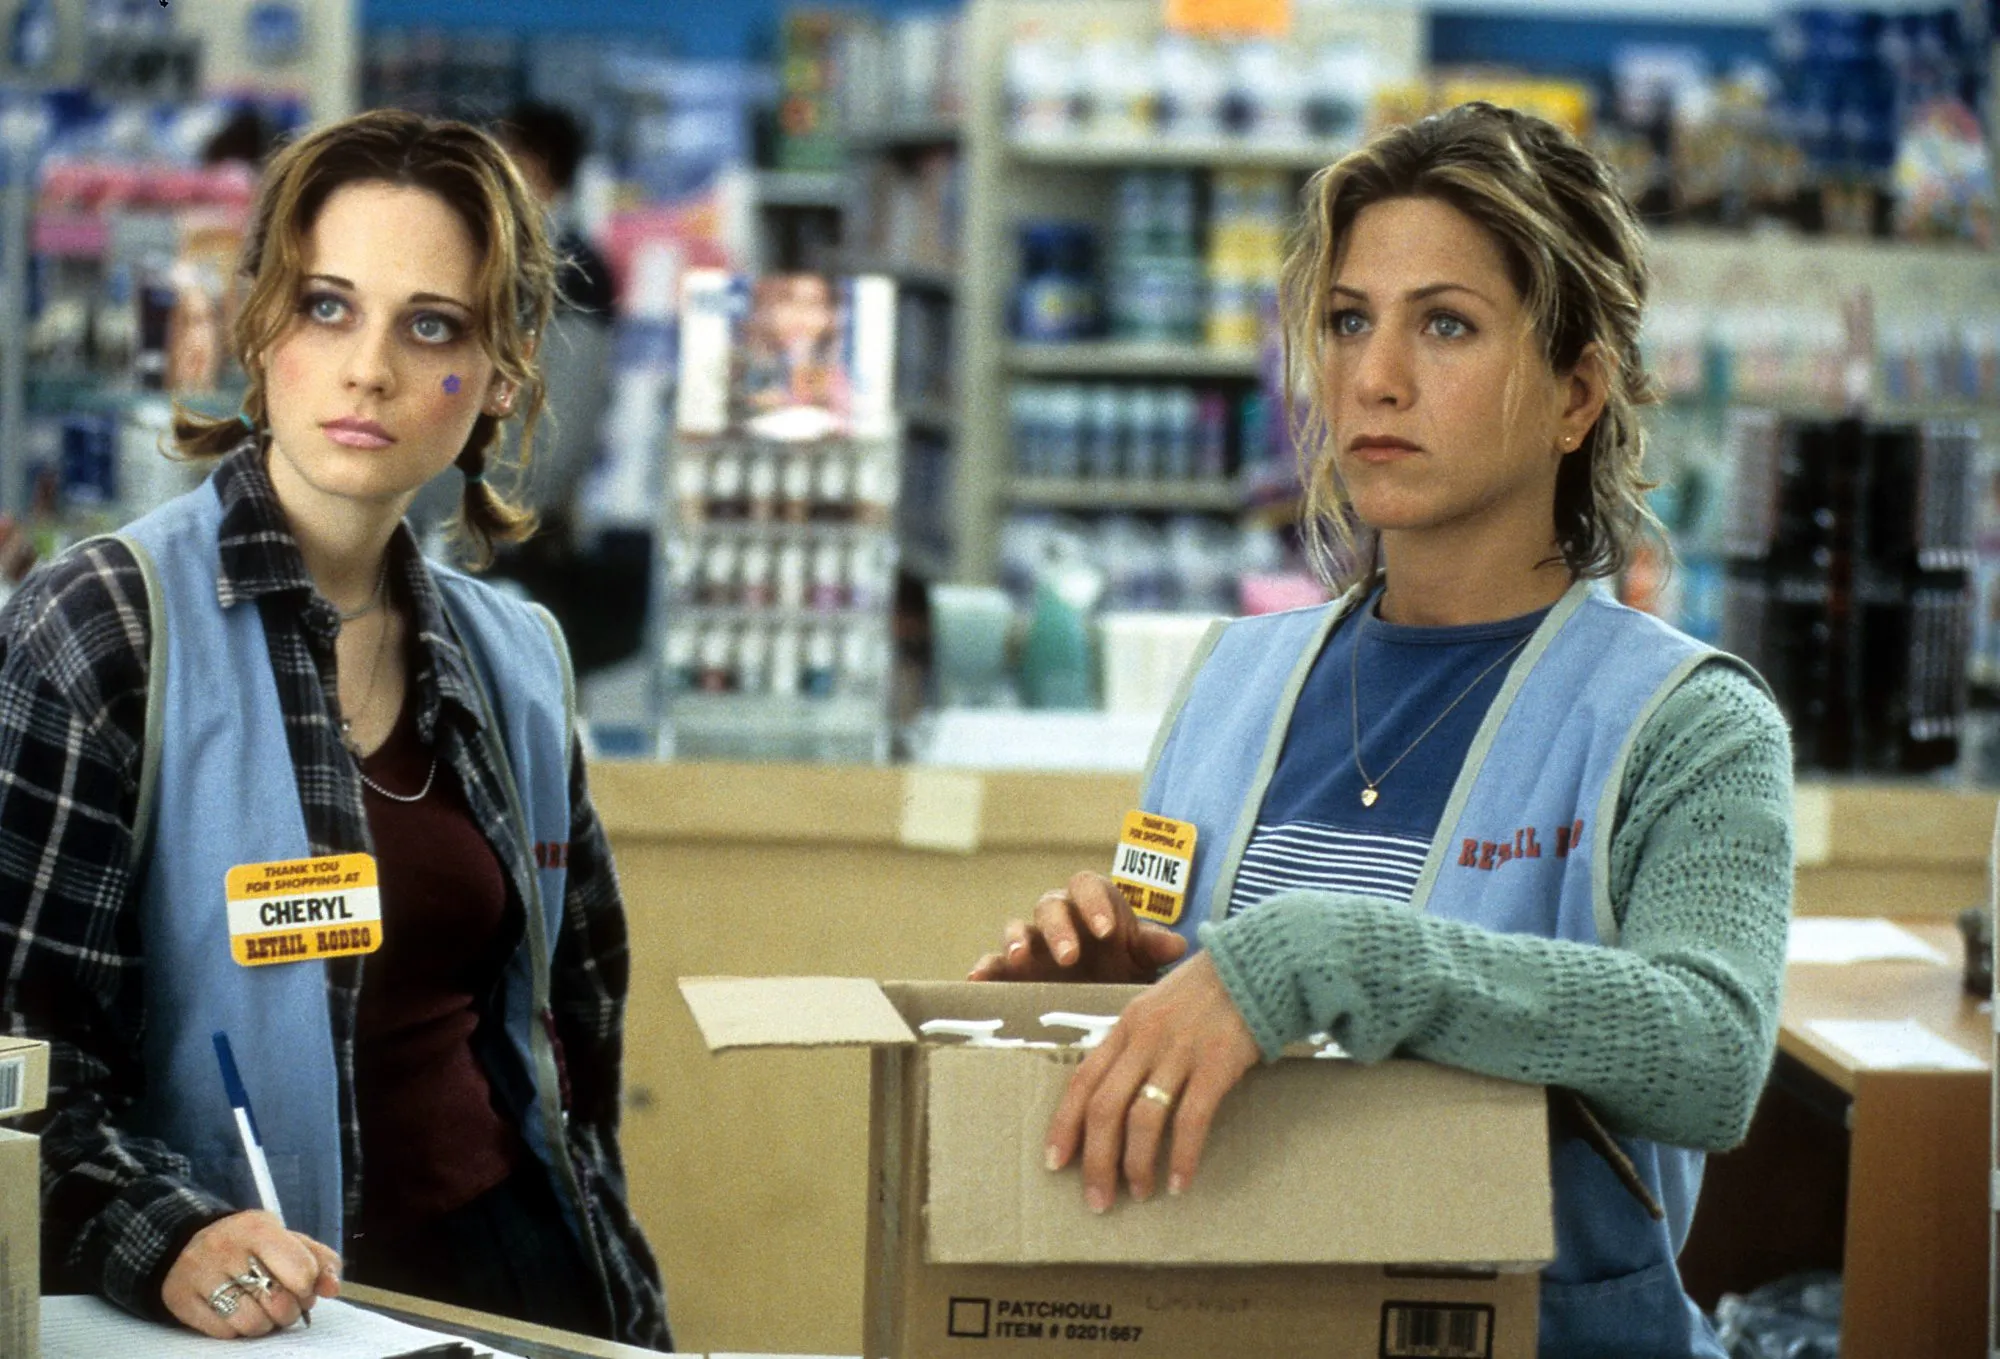Describe a realistic scenario where Cheryl and Justine are dealing with a store emergency. In a realistic scenario, Cheryl and Justine might be dealing with a sudden rush of customers during a busy sale period. Justine is in charge of stocking new promotional items on the shelves, but she notices that supplies are running low much earlier than expected. Cheryl, meanwhile, is trying to handle a long line at the cashier but gets interrupted by a concerned customer reporting a spill in one of the aisles. Both women must quickly coordinate their efforts to manage the chaos, ensuring customer safety and satisfaction while maintaining store operations smoothly. 